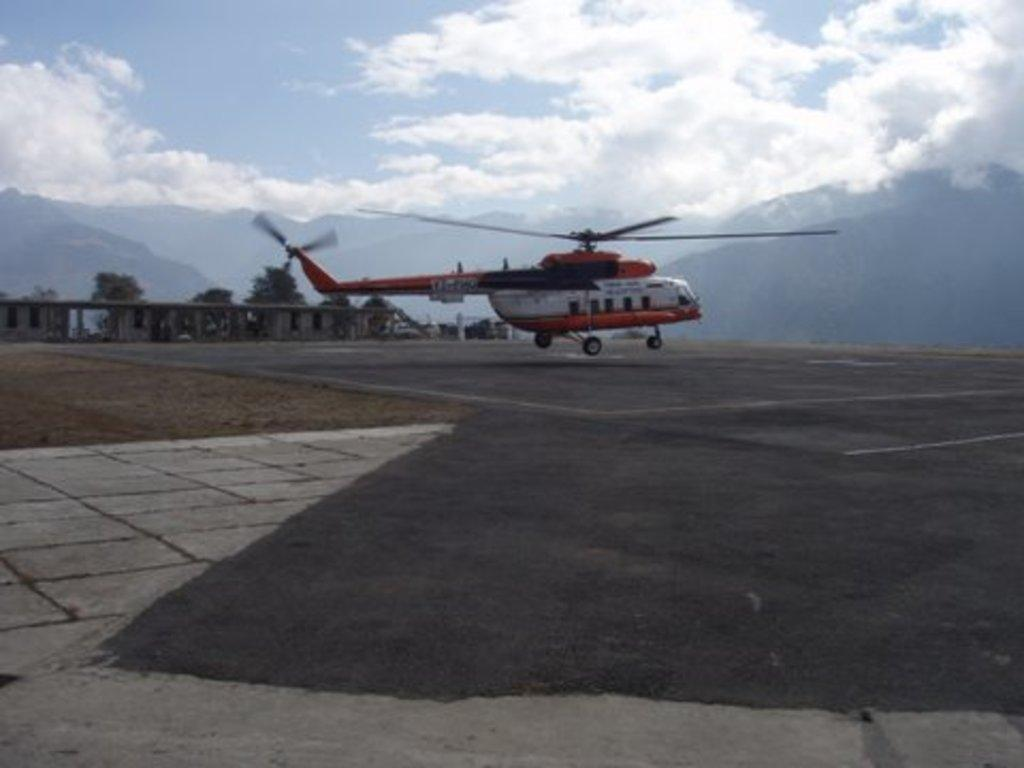What is the main subject of the image? The main subject of the image is a helicopter. What can be seen at the bottom of the image? There is a road at the bottom of the image. What is visible in the background of the image? Mountains, trees, the sky, and clouds can be seen in the background of the image. How many frogs are sitting on the helicopter blades in the image? There are no frogs or helicopter blades present in the image. What are the children doing in the image? There are no children present in the image. 